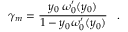Convert formula to latex. <formula><loc_0><loc_0><loc_500><loc_500>\gamma _ { m } = { \frac { y _ { 0 } \, \omega _ { 0 } ^ { \prime } ( y _ { 0 } ) } { 1 - y _ { 0 } \omega _ { 0 } ^ { \prime } ( y _ { 0 } ) } } \, .</formula> 